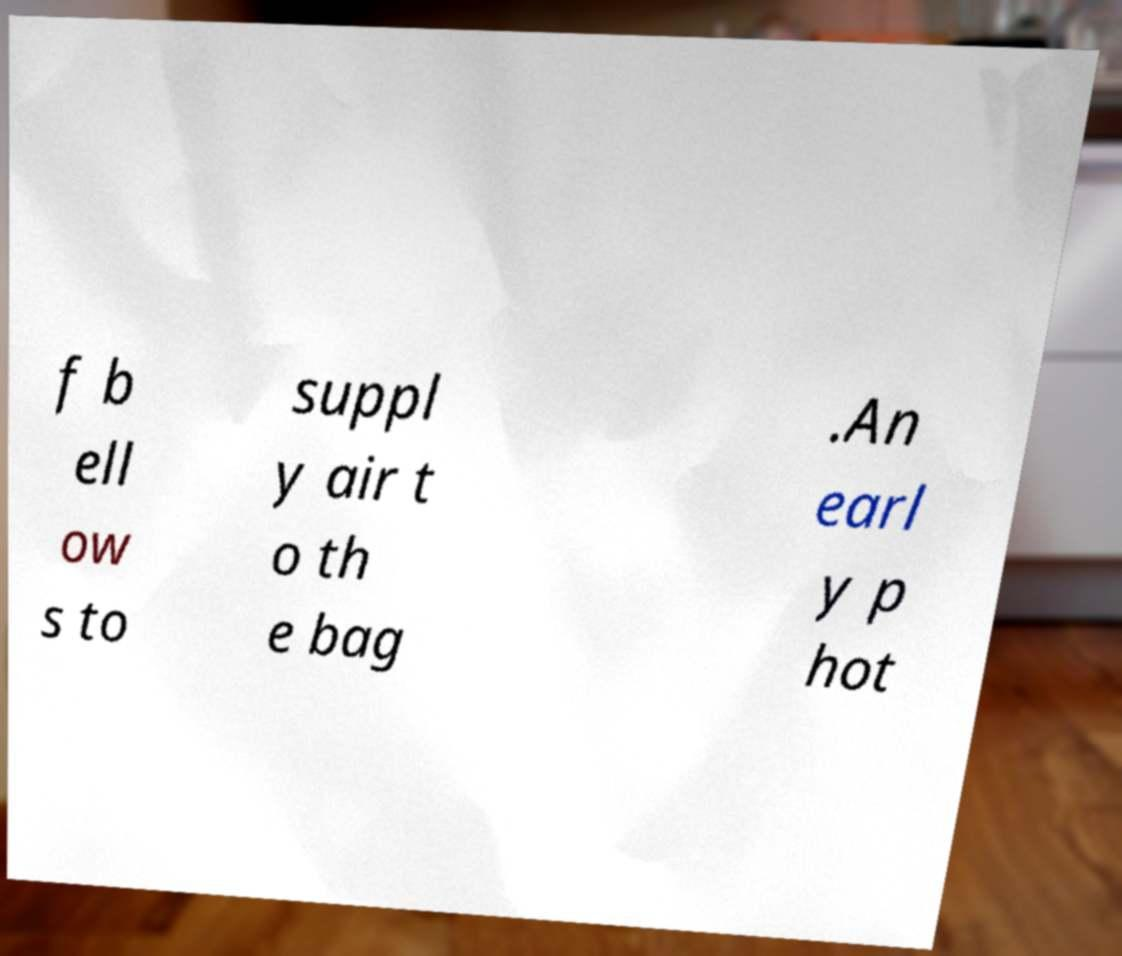Can you accurately transcribe the text from the provided image for me? f b ell ow s to suppl y air t o th e bag .An earl y p hot 